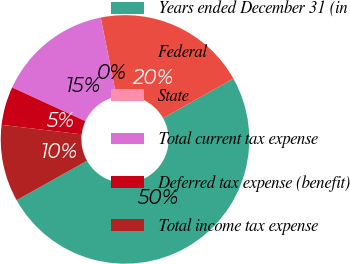Convert chart. <chart><loc_0><loc_0><loc_500><loc_500><pie_chart><fcel>Years ended December 31 (in<fcel>Federal<fcel>State<fcel>Total current tax expense<fcel>Deferred tax expense (benefit)<fcel>Total income tax expense<nl><fcel>50.0%<fcel>20.0%<fcel>0.0%<fcel>15.0%<fcel>5.0%<fcel>10.0%<nl></chart> 